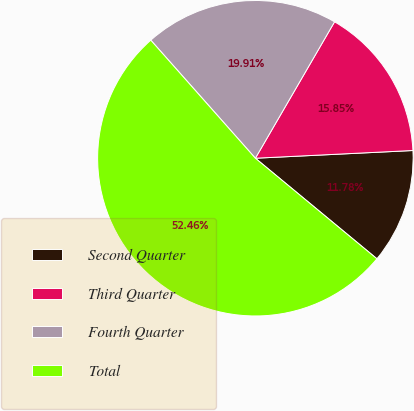Convert chart. <chart><loc_0><loc_0><loc_500><loc_500><pie_chart><fcel>Second Quarter<fcel>Third Quarter<fcel>Fourth Quarter<fcel>Total<nl><fcel>11.78%<fcel>15.85%<fcel>19.91%<fcel>52.46%<nl></chart> 